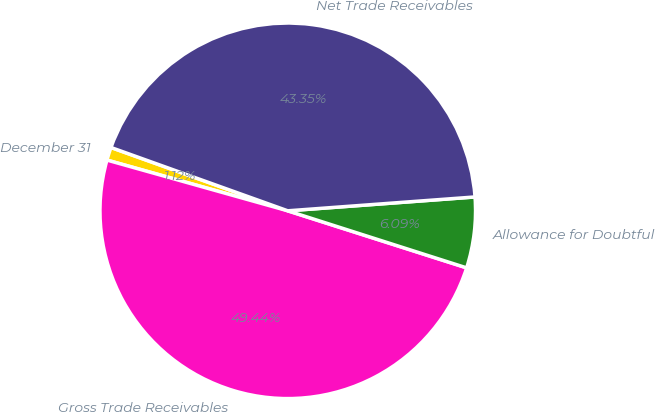<chart> <loc_0><loc_0><loc_500><loc_500><pie_chart><fcel>December 31<fcel>Gross Trade Receivables<fcel>Allowance for Doubtful<fcel>Net Trade Receivables<nl><fcel>1.12%<fcel>49.44%<fcel>6.09%<fcel>43.35%<nl></chart> 